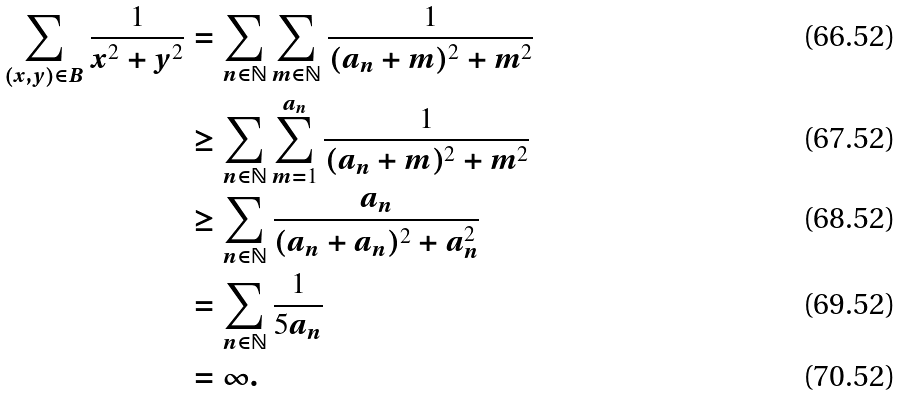<formula> <loc_0><loc_0><loc_500><loc_500>\sum _ { ( x , y ) \in B } \frac { 1 } { x ^ { 2 } + y ^ { 2 } } & = \sum _ { n \in \mathbb { N } } \sum _ { m \in \mathbb { N } } \frac { 1 } { ( a _ { n } + m ) ^ { 2 } + m ^ { 2 } } \\ & \geq \sum _ { n \in \mathbb { N } } \sum _ { m = 1 } ^ { a _ { n } } \frac { 1 } { ( a _ { n } + m ) ^ { 2 } + m ^ { 2 } } \\ & \geq \sum _ { n \in \mathbb { N } } \frac { a _ { n } } { ( a _ { n } + a _ { n } ) ^ { 2 } + a _ { n } ^ { 2 } } \\ & = \sum _ { n \in \mathbb { N } } \frac { 1 } { 5 a _ { n } } \\ & = \infty .</formula> 